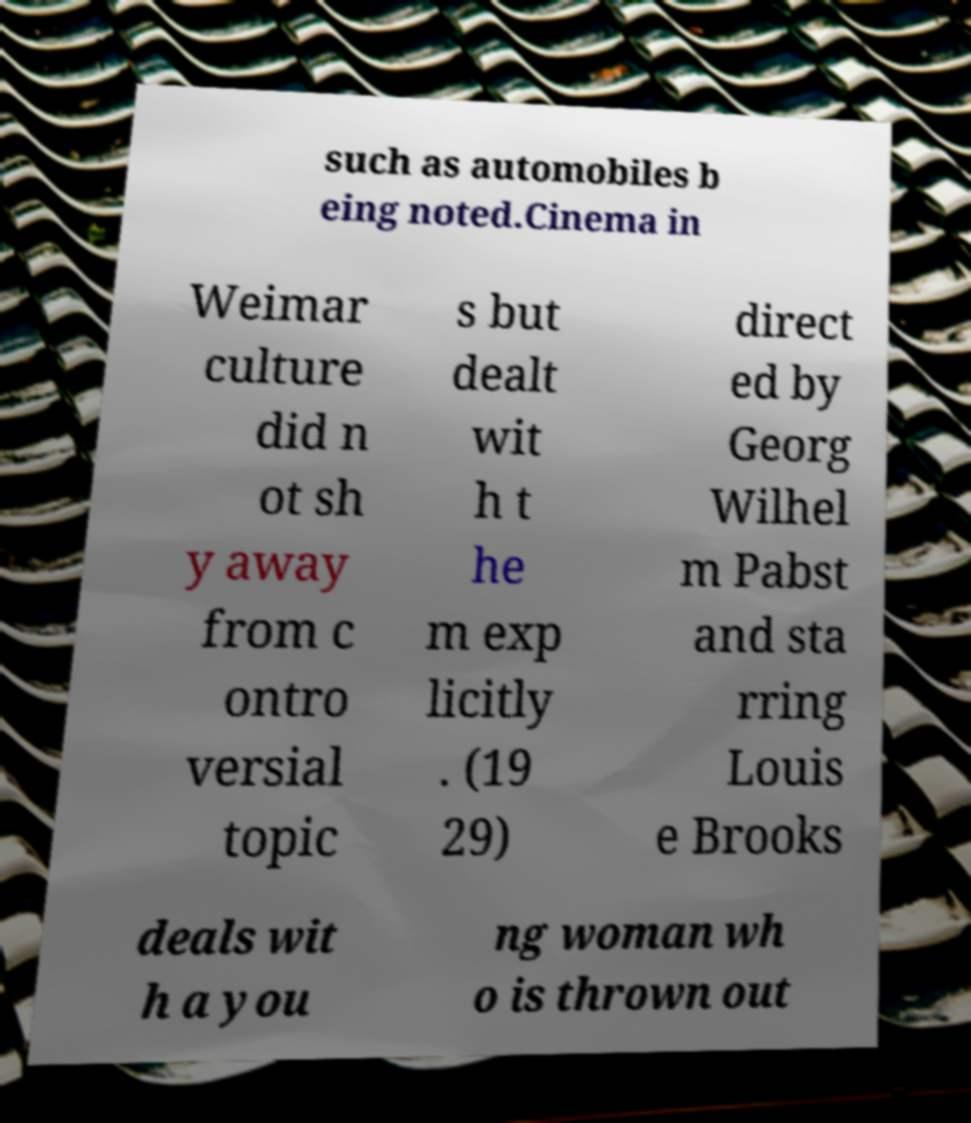I need the written content from this picture converted into text. Can you do that? such as automobiles b eing noted.Cinema in Weimar culture did n ot sh y away from c ontro versial topic s but dealt wit h t he m exp licitly . (19 29) direct ed by Georg Wilhel m Pabst and sta rring Louis e Brooks deals wit h a you ng woman wh o is thrown out 